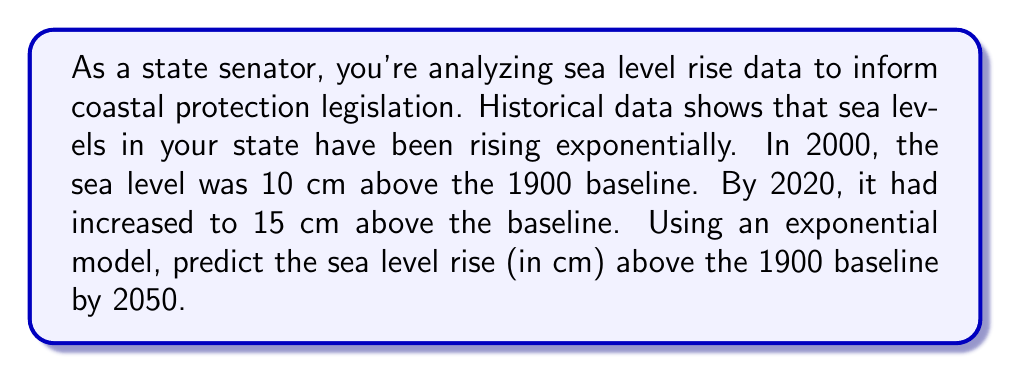What is the answer to this math problem? Let's approach this step-by-step using an exponential model:

1) The general form of an exponential model is:
   $$y = ae^{rt}$$
   where $y$ is the sea level rise, $a$ is the initial value, $r$ is the growth rate, and $t$ is the time in years.

2) We have two data points:
   - In 2000 (t = 0): y = 10 cm
   - In 2020 (t = 20): y = 15 cm

3) Let's use these to set up our equations:
   $$10 = ae^{r(0)}$$
   $$15 = ae^{r(20)}$$

4) From the first equation, we can deduce that $a = 10$.

5) Now, let's solve for $r$ using the second equation:
   $$15 = 10e^{20r}$$

6) Dividing both sides by 10:
   $$1.5 = e^{20r}$$

7) Taking the natural log of both sides:
   $$\ln(1.5) = 20r$$

8) Solving for $r$:
   $$r = \frac{\ln(1.5)}{20} \approx 0.0203$$

9) Now we have our full model:
   $$y = 10e^{0.0203t}$$

10) To predict the sea level rise in 2050, we need to calculate for t = 50 (50 years after 2000):
    $$y = 10e^{0.0203(50)} \approx 27.61$$

Therefore, the predicted sea level rise in 2050 is approximately 27.61 cm above the 1900 baseline.
Answer: 27.61 cm 